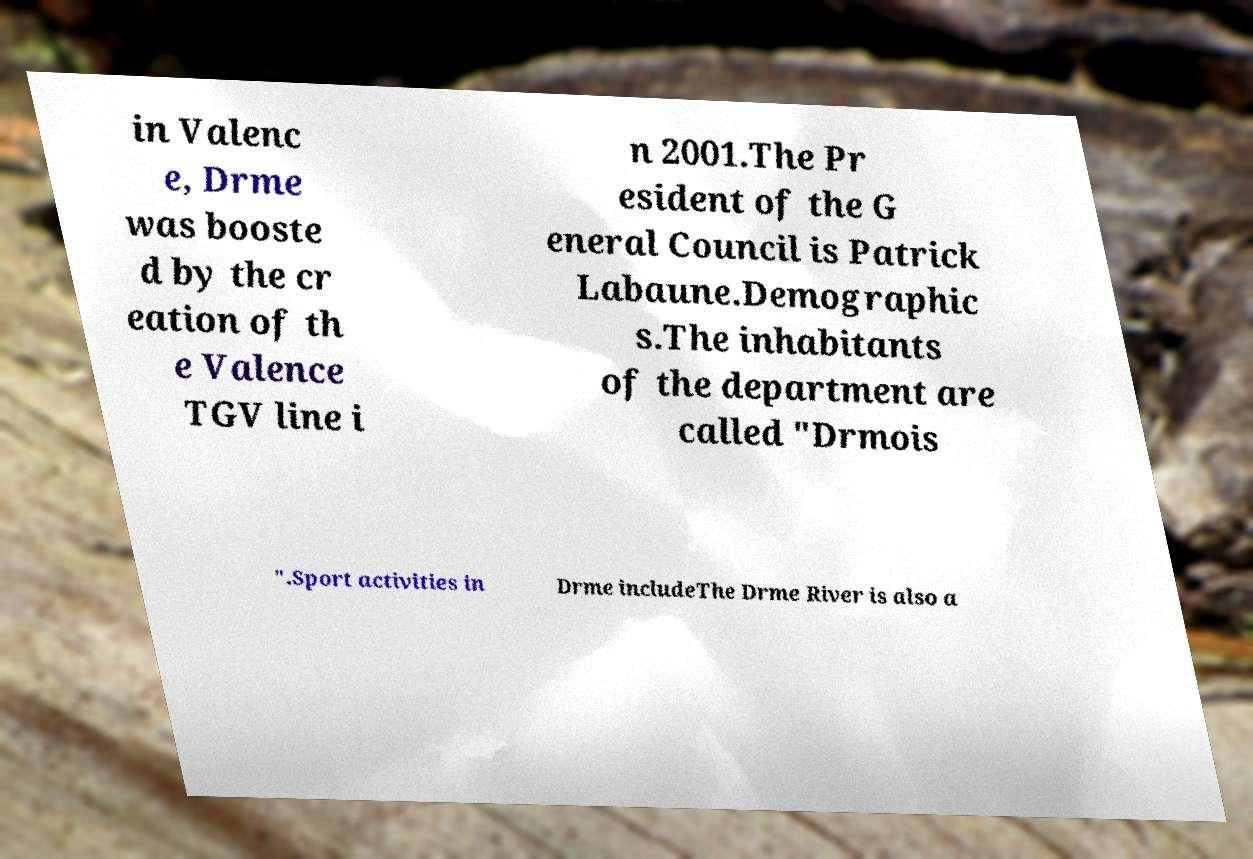Can you read and provide the text displayed in the image?This photo seems to have some interesting text. Can you extract and type it out for me? in Valenc e, Drme was booste d by the cr eation of th e Valence TGV line i n 2001.The Pr esident of the G eneral Council is Patrick Labaune.Demographic s.The inhabitants of the department are called "Drmois ".Sport activities in Drme includeThe Drme River is also a 